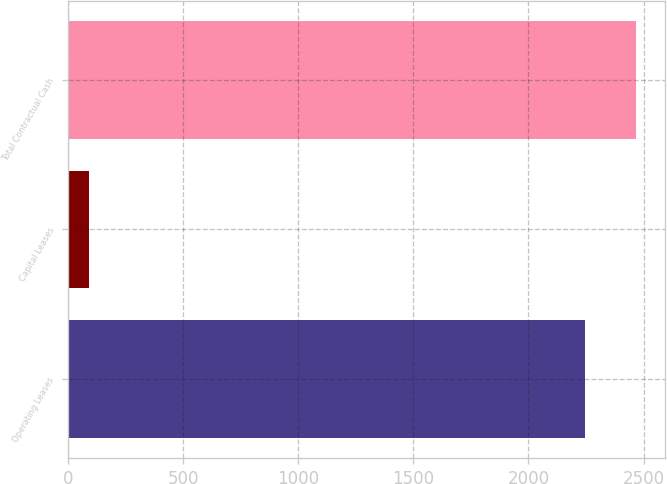<chart> <loc_0><loc_0><loc_500><loc_500><bar_chart><fcel>Operating Leases<fcel>Capital Leases<fcel>Total Contractual Cash<nl><fcel>2244<fcel>90<fcel>2468.4<nl></chart> 